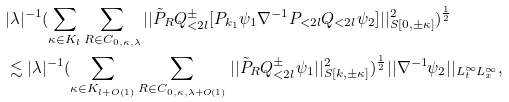Convert formula to latex. <formula><loc_0><loc_0><loc_500><loc_500>& | \lambda | ^ { - 1 } ( \sum _ { \kappa \in K _ { l } } \sum _ { R \in C _ { 0 , \kappa , \lambda } } | | \tilde { P } _ { R } Q ^ { \pm } _ { < 2 l } [ P _ { k _ { 1 } } \psi _ { 1 } \nabla ^ { - 1 } P _ { < 2 l } Q _ { < 2 l } \psi _ { 2 } ] | | _ { S [ 0 , \pm \kappa ] } ^ { 2 } ) ^ { \frac { 1 } { 2 } } \\ & \lesssim | \lambda | ^ { - 1 } ( \sum _ { \kappa \in K _ { l + O ( 1 ) } } \sum _ { R \in C _ { 0 , \kappa , \lambda + O ( 1 ) } } | | \tilde { P } _ { R } Q ^ { \pm } _ { < 2 l } \psi _ { 1 } | | _ { S [ k , \pm \kappa ] } ^ { 2 } ) ^ { \frac { 1 } { 2 } } | | \nabla ^ { - 1 } \psi _ { 2 } | | _ { L _ { t } ^ { \infty } L _ { x } ^ { \infty } } , \\</formula> 